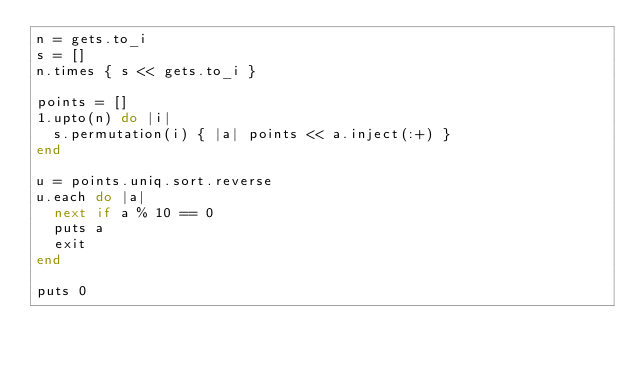<code> <loc_0><loc_0><loc_500><loc_500><_Ruby_>n = gets.to_i
s = []
n.times { s << gets.to_i }

points = []
1.upto(n) do |i|
  s.permutation(i) { |a| points << a.inject(:+) }
end

u = points.uniq.sort.reverse
u.each do |a|
  next if a % 10 == 0
  puts a
  exit
end

puts 0
</code> 